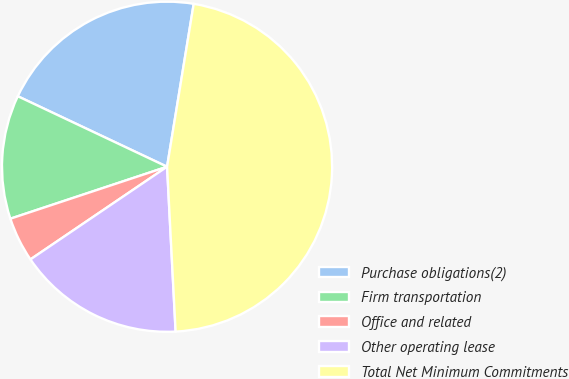<chart> <loc_0><loc_0><loc_500><loc_500><pie_chart><fcel>Purchase obligations(2)<fcel>Firm transportation<fcel>Office and related<fcel>Other operating lease<fcel>Total Net Minimum Commitments<nl><fcel>20.56%<fcel>12.12%<fcel>4.39%<fcel>16.34%<fcel>46.6%<nl></chart> 